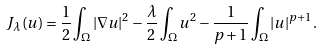Convert formula to latex. <formula><loc_0><loc_0><loc_500><loc_500>J _ { \lambda } ( u ) = \frac { 1 } { 2 } \int _ { \Omega } | \nabla u | ^ { 2 } - \frac { \lambda } { 2 } \int _ { \Omega } u ^ { 2 } - \frac { 1 } { p + 1 } \int _ { \Omega } | u | ^ { p + 1 } .</formula> 